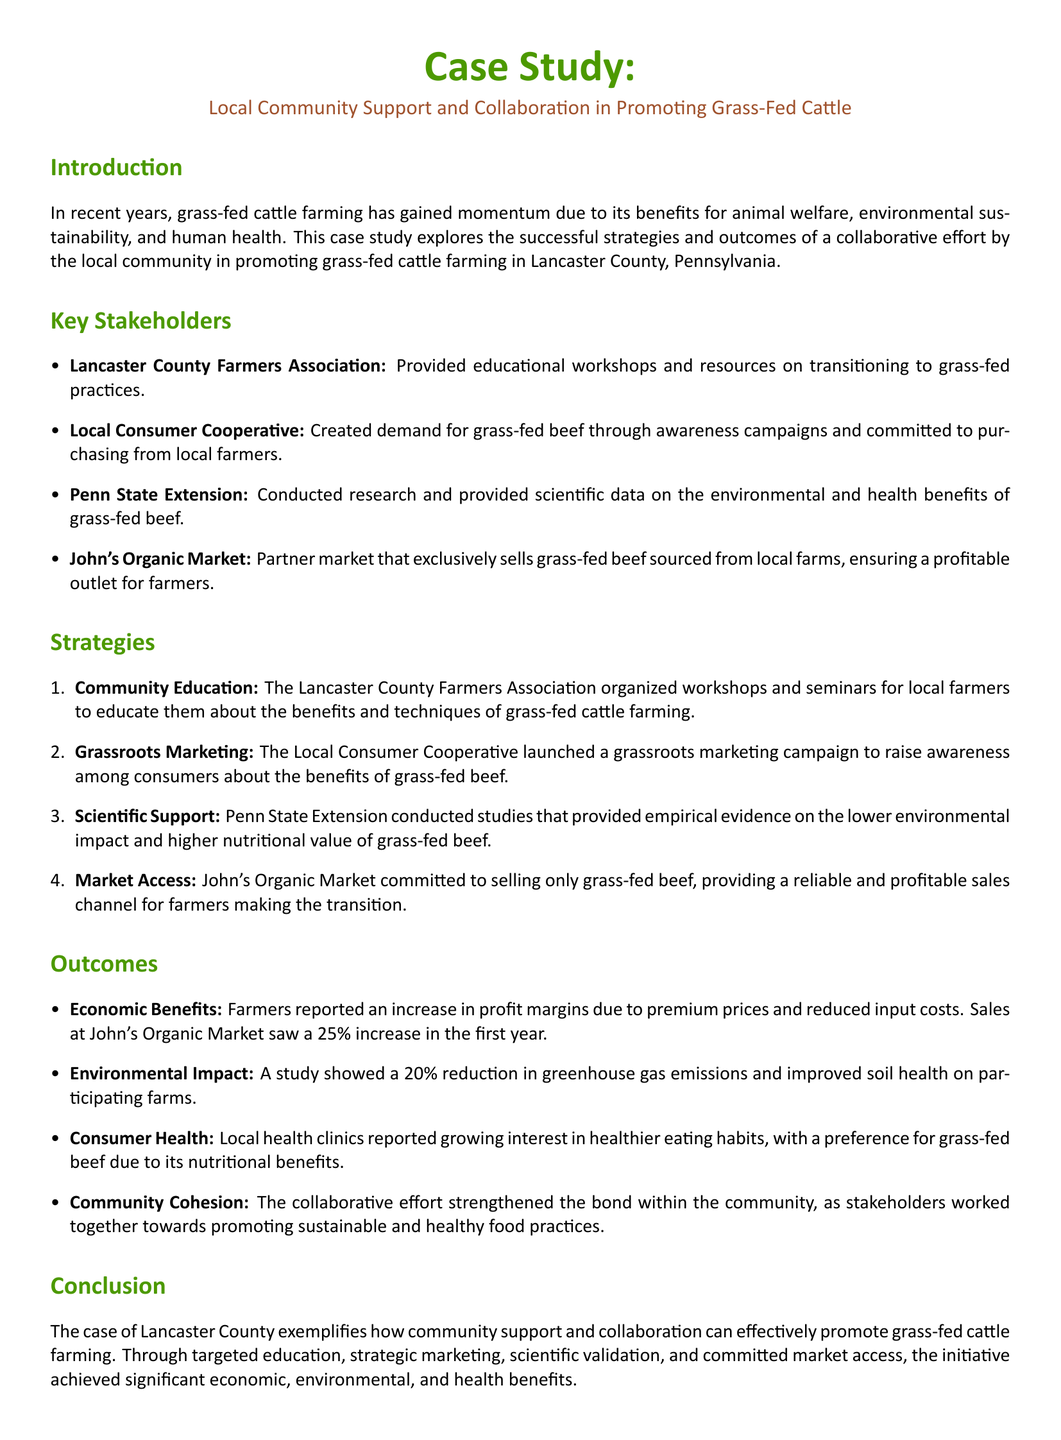What is the case study's focus? The focus of the case study is on local community support and collaboration in promoting grass-fed cattle farming.
Answer: Local community support and collaboration in promoting grass-fed cattle Who organized the educational workshops? The educational workshops were organized by the Lancaster County Farmers Association.
Answer: Lancaster County Farmers Association What percentage increase in sales did John's Organic Market experience in the first year? John's Organic Market experienced a 25 percent increase in sales in the first year.
Answer: 25 percent What type of marketing campaign did the Local Consumer Cooperative launch? The Local Consumer Cooperative launched a grassroots marketing campaign to raise awareness.
Answer: Grassroots marketing campaign What was the reported reduction in greenhouse gas emissions on participating farms? The reported reduction in greenhouse gas emissions on participating farms was 20 percent.
Answer: 20 percent 